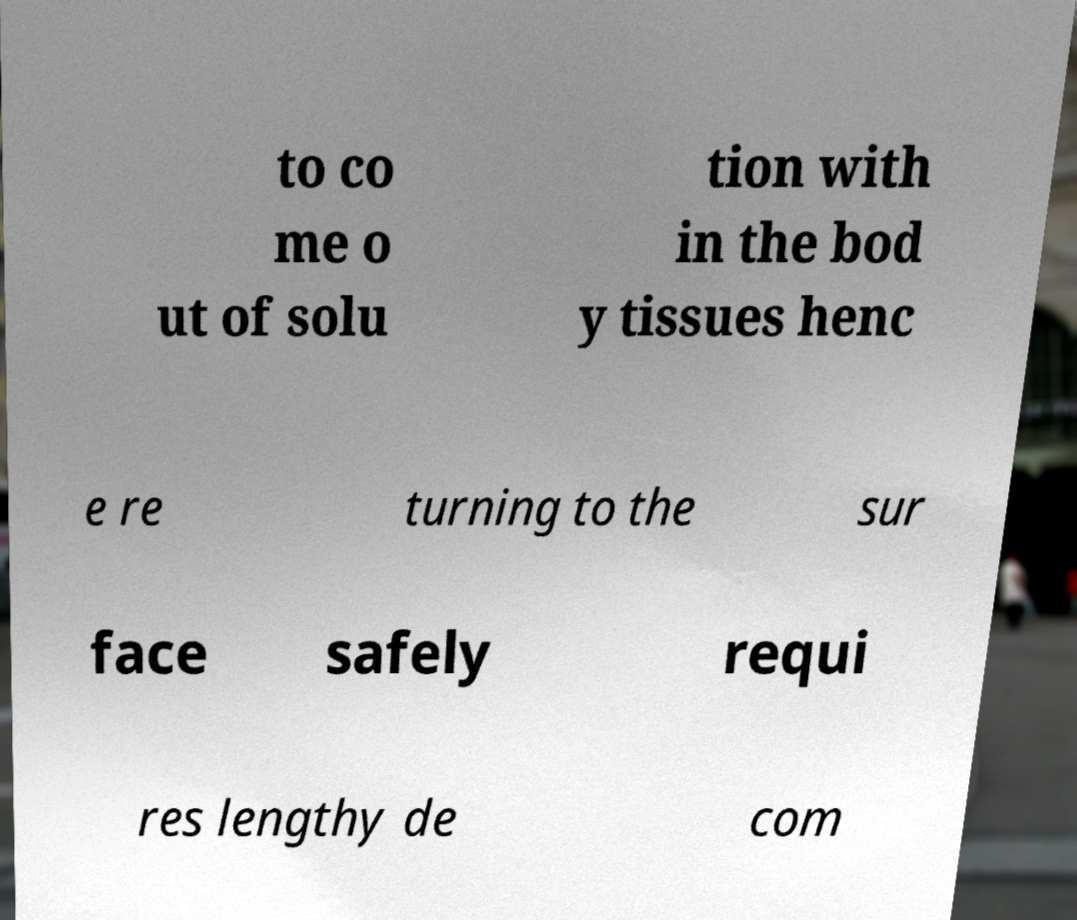Could you extract and type out the text from this image? to co me o ut of solu tion with in the bod y tissues henc e re turning to the sur face safely requi res lengthy de com 